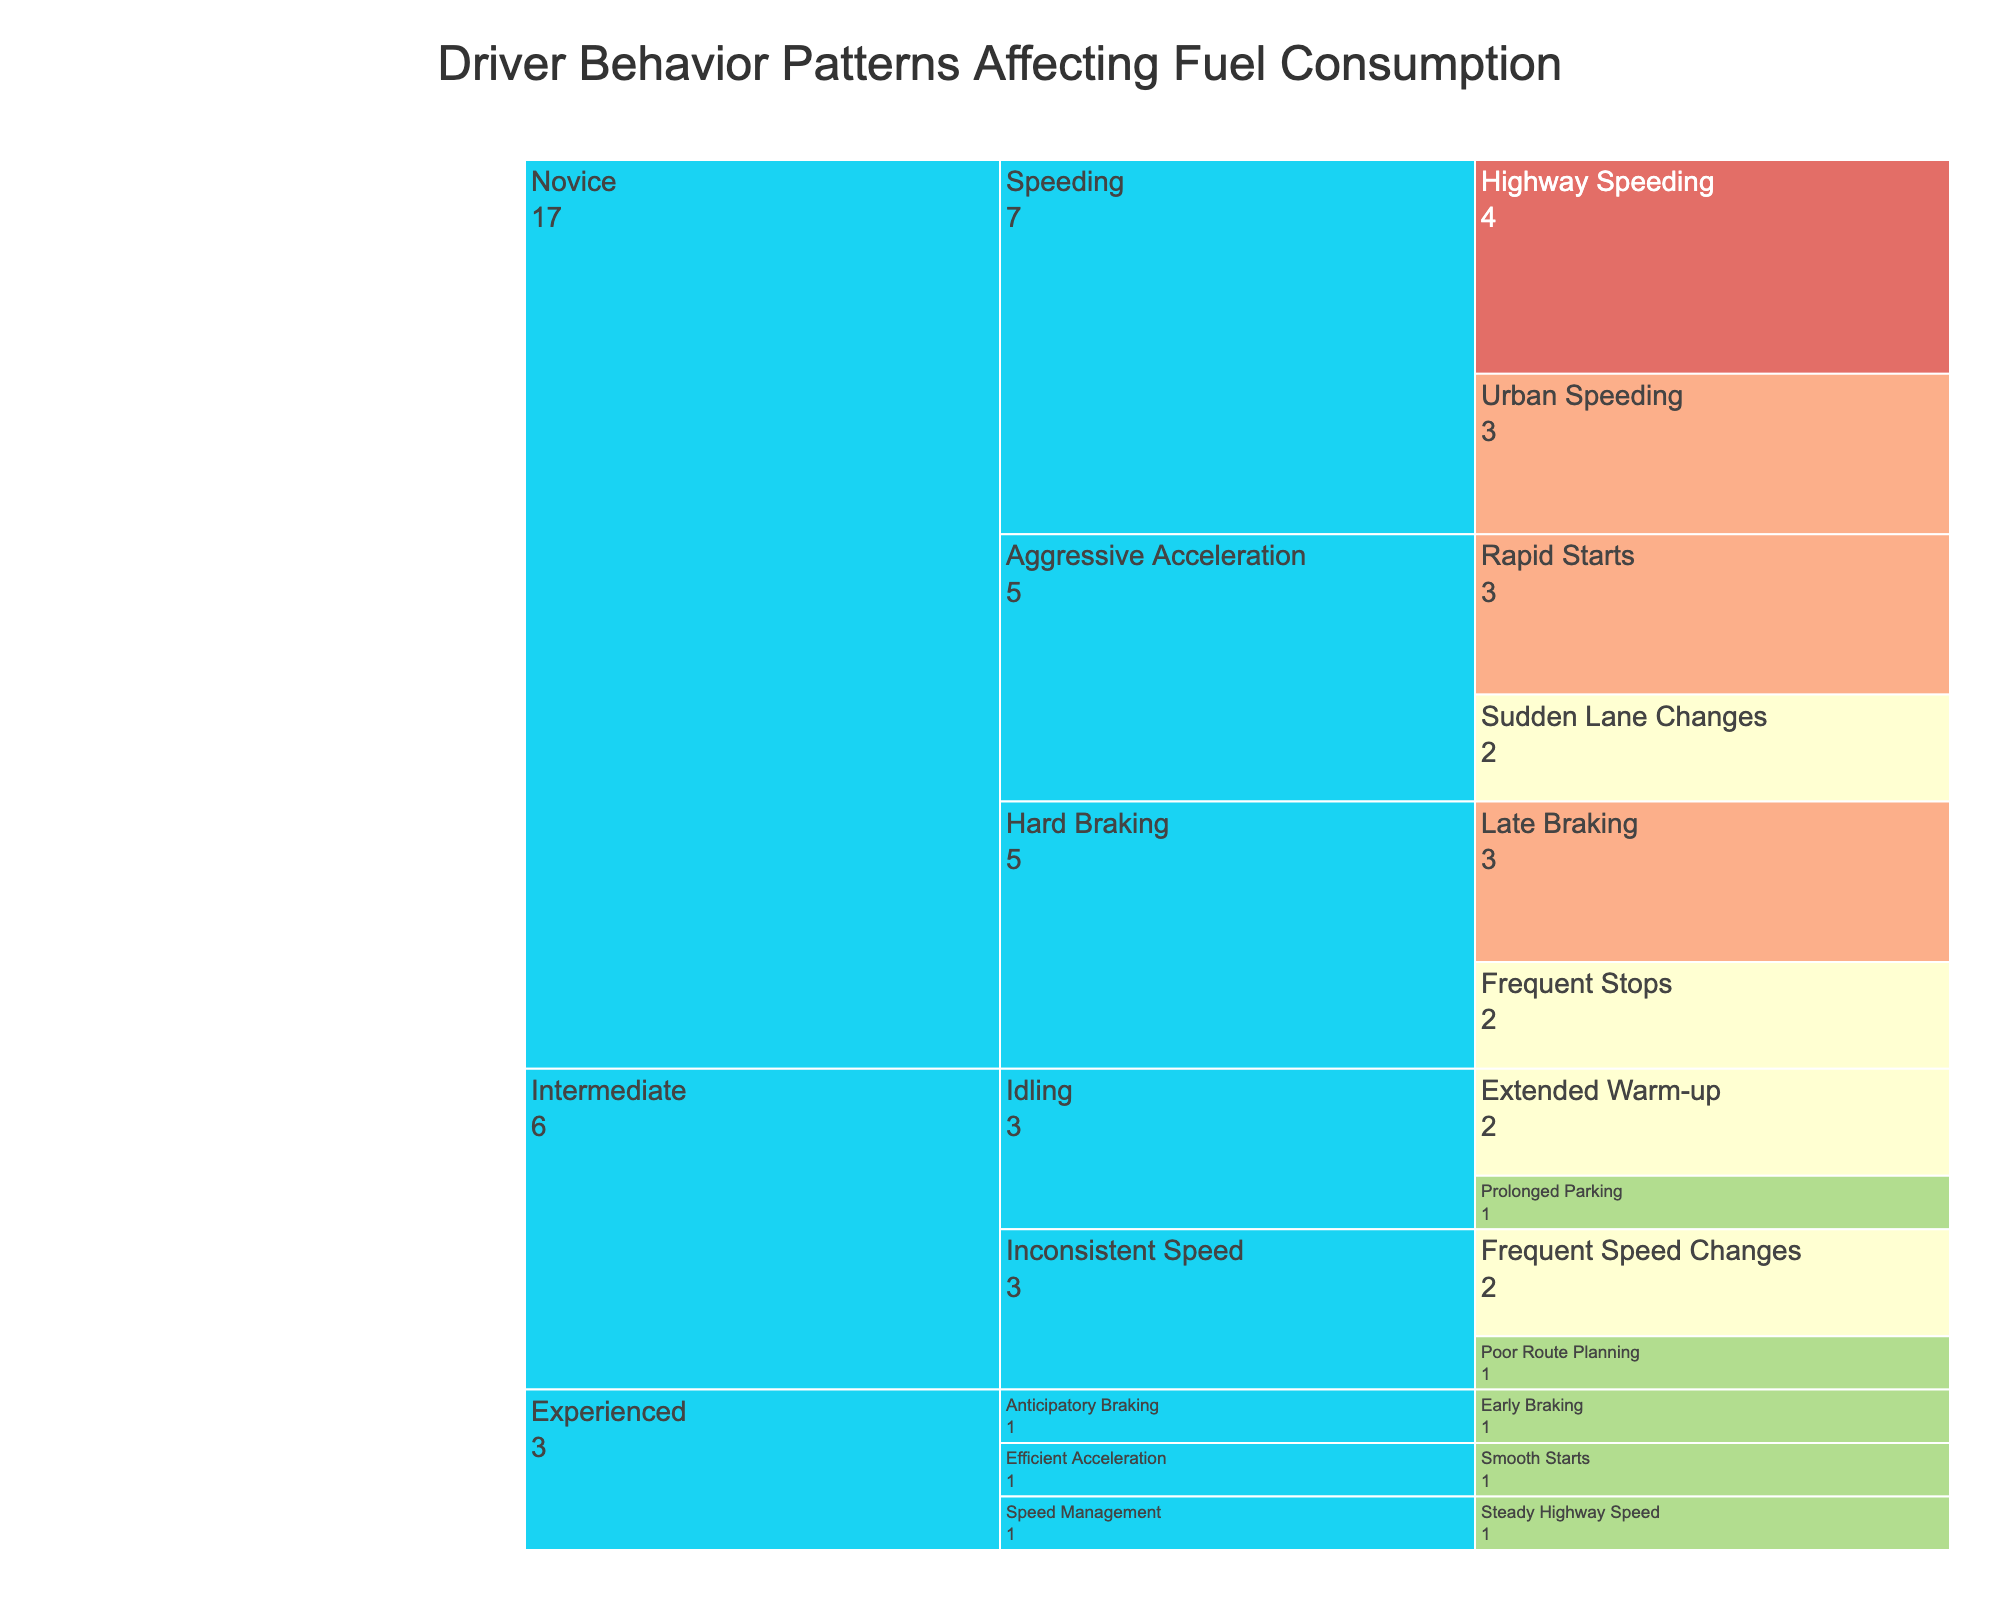What's the title of the figure? The title is usually displayed at the top of the figure. From the data description provided, the title can be found in the figure's configuration.
Answer: Driver Behavior Patterns Affecting Fuel Consumption Which driver experience level has the most sub-behaviors listed in the chart? By examining the chart structure, you can count the sub-behaviors under each driver experience level. The level with the most sub-behaviors is the one with the highest count.
Answer: Novice How does the fuel consumption impact of 'Urban Speeding' compare to 'Highway Speeding' for novice drivers? Look at the fuel consumption impact values for both sub-behaviors under the novice driver category. Compare the values to determine which has a higher impact.
Answer: Urban Speeding impact is High, Highway Speeding impact is Very High What's the sum of fuel consumption impacts for 'Efficient Acceleration' sub-behaviors among experienced drivers? Identify the fuel consumption impacts for the 'Efficient Acceleration' sub-behaviors ('Smooth Starts' and 'Gradual Lane Changes'). Convert these qualitative values to their numeric equivalents and sum them.
Answer: Low + Very Low Which driving behavior has a higher impact on fuel consumption, 'Hard Braking' or 'Idling' for intermediate drivers? By examining the impacts of the sub-behaviors under 'Hard Braking' and 'Idling' for intermediate drivers, compare their highest impact values.
Answer: Hard Braking (High for Novice, not specified for Intermediate) How many behaviors affect fuel consumption for experienced drivers? Count the number of main behaviors under the experienced driver category. Each main behavior has sub-behaviors, but the count of main behaviors is required.
Answer: 3 If 'Rapid Starts' and 'Late Braking' both affect fuel consumption for novice drivers, which one has a higher impact? Compare the fuel consumption impact values for 'Rapid Starts' and 'Late Braking' for novice drivers. The one with the higher impact value is the answer.
Answer: Late Braking What's the difference in fuel consumption impacts between 'Frequent Stops' and 'Coasting to Stops' sub-behaviors? Identify the fuel consumption impacts of 'Frequent Stops' and 'Coasting to Stops'. Convert these impacts from qualitative to quantitative values and calculate the difference.
Answer: Medium for 'Frequent Stops', Very Low for 'Coasting to Stops', so the difference is Medium - Very Low Are there any behaviors under experienced drivers with a 'Very Low' impact on fuel consumption? Check each sub-behavior under the experienced drivers category. Identify if any of these have a 'Very Low' impact on fuel consumption.
Answer: Yes 